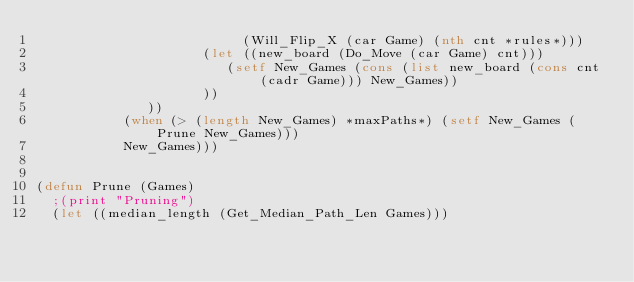<code> <loc_0><loc_0><loc_500><loc_500><_Lisp_>                          (Will_Flip_X (car Game) (nth cnt *rules*)))
                     (let ((new_board (Do_Move (car Game) cnt)))
                        (setf New_Games (cons (list new_board (cons cnt (cadr Game))) New_Games))
                     ))
              ))
           (when (> (length New_Games) *maxPaths*) (setf New_Games (Prune New_Games)))
           New_Games)))


(defun Prune (Games)
  ;(print "Pruning")
  (let ((median_length (Get_Median_Path_Len Games)))</code> 